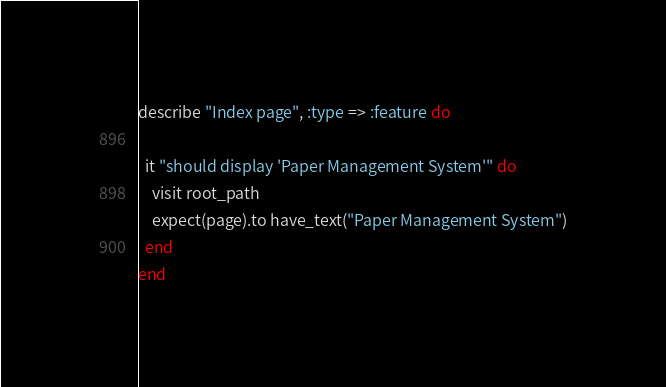<code> <loc_0><loc_0><loc_500><loc_500><_Ruby_>describe "Index page", :type => :feature do
  
  it "should display 'Paper Management System'" do
    visit root_path
    expect(page).to have_text("Paper Management System")
  end
end</code> 